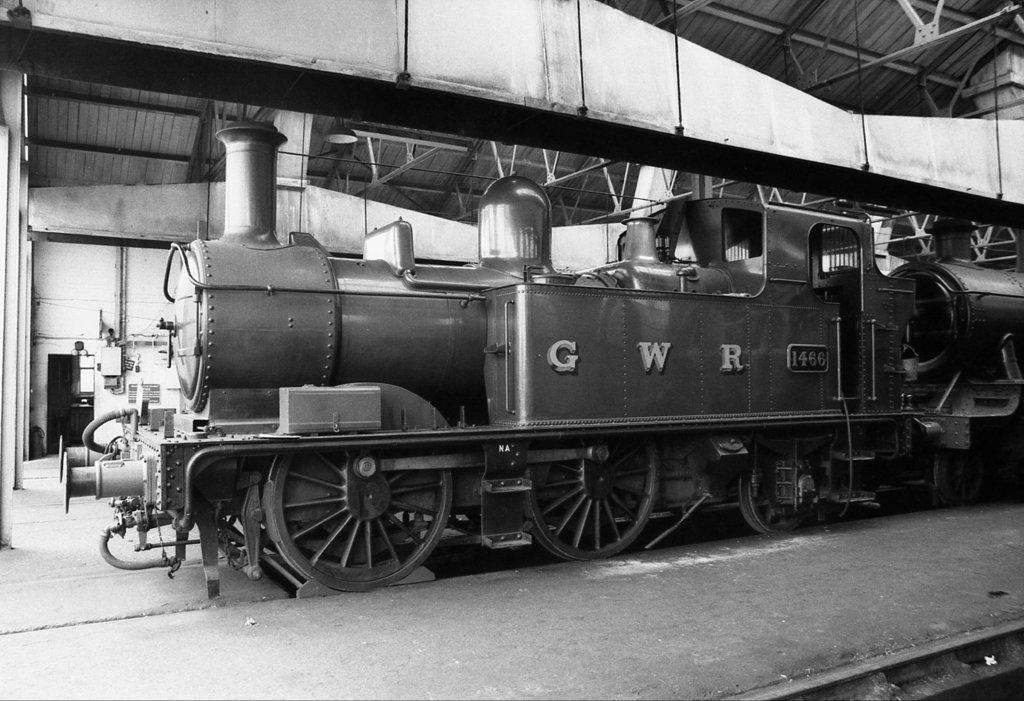Please provide a concise description of this image. In this image I can see the black and white picture in which I can see a train on the ground. I can see the ceiling, the wall, few other objects and the door. 